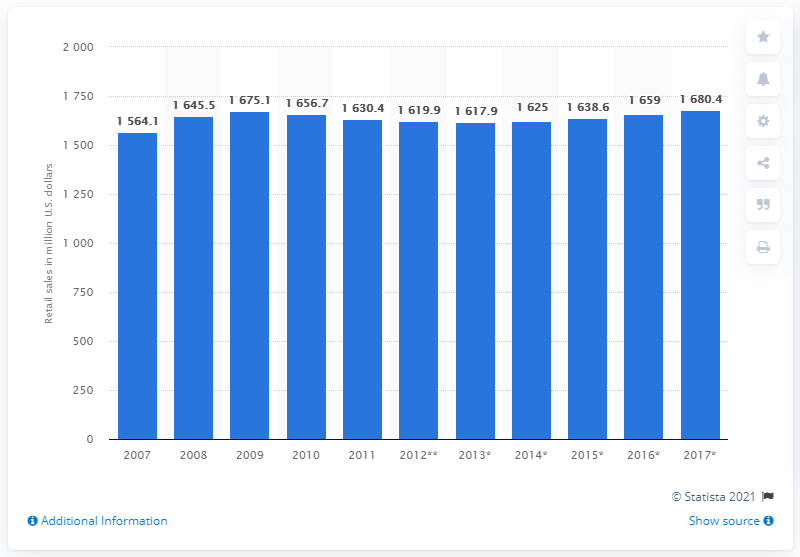List a handful of essential elements in this visual. According to estimates, the packaged organic food market in the UK was valued at almost 1.63 billion U.S dollars in 2007. The estimated value of the packaged organic food market in the United States in 2017 was 1638.6 million dollars. 